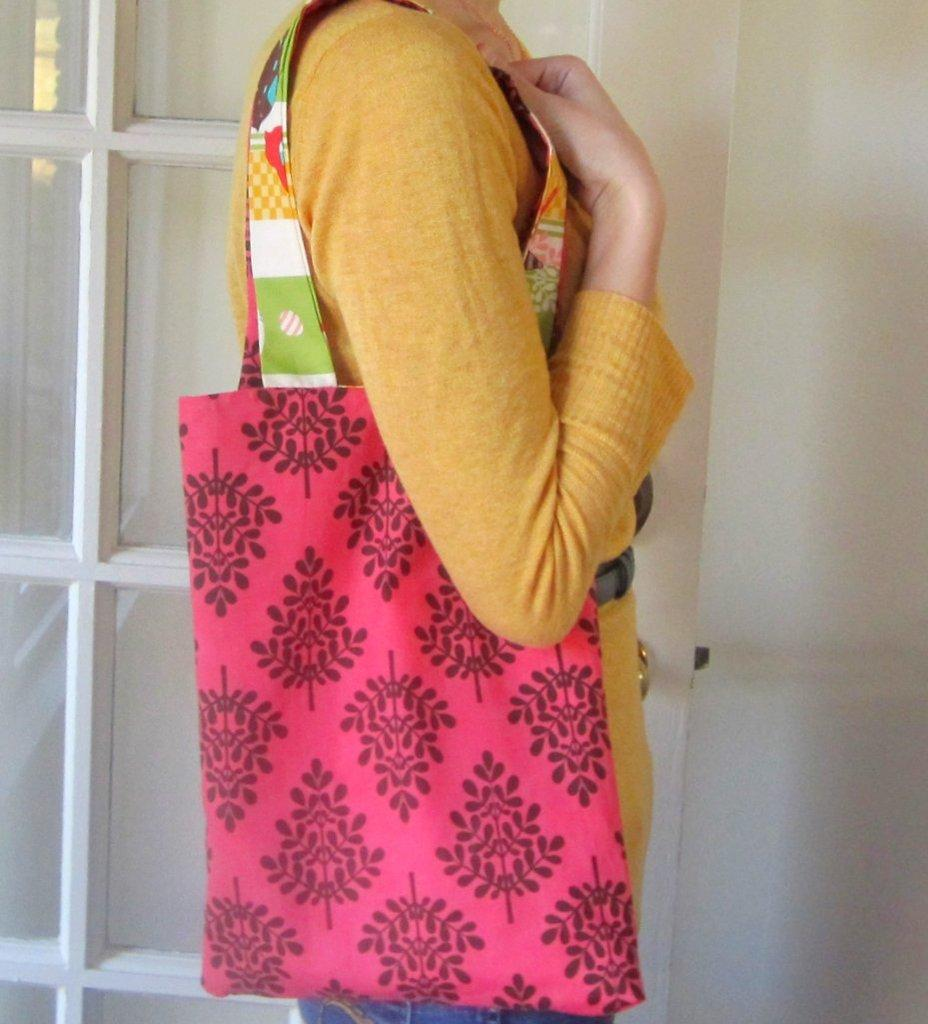What can be seen in the image? There is a person in the image. What is the person carrying? The person is carrying a handbag. Can you describe the handbag? The handbag has colors pink, green, white, and yellow, and it is made of cloth. What is visible in the background of the image? There is a door and a wall in the background of the image. What type of behavior is the person exhibiting in the image? The image does not provide information about the person's behavior, so it cannot be determined from the image. 